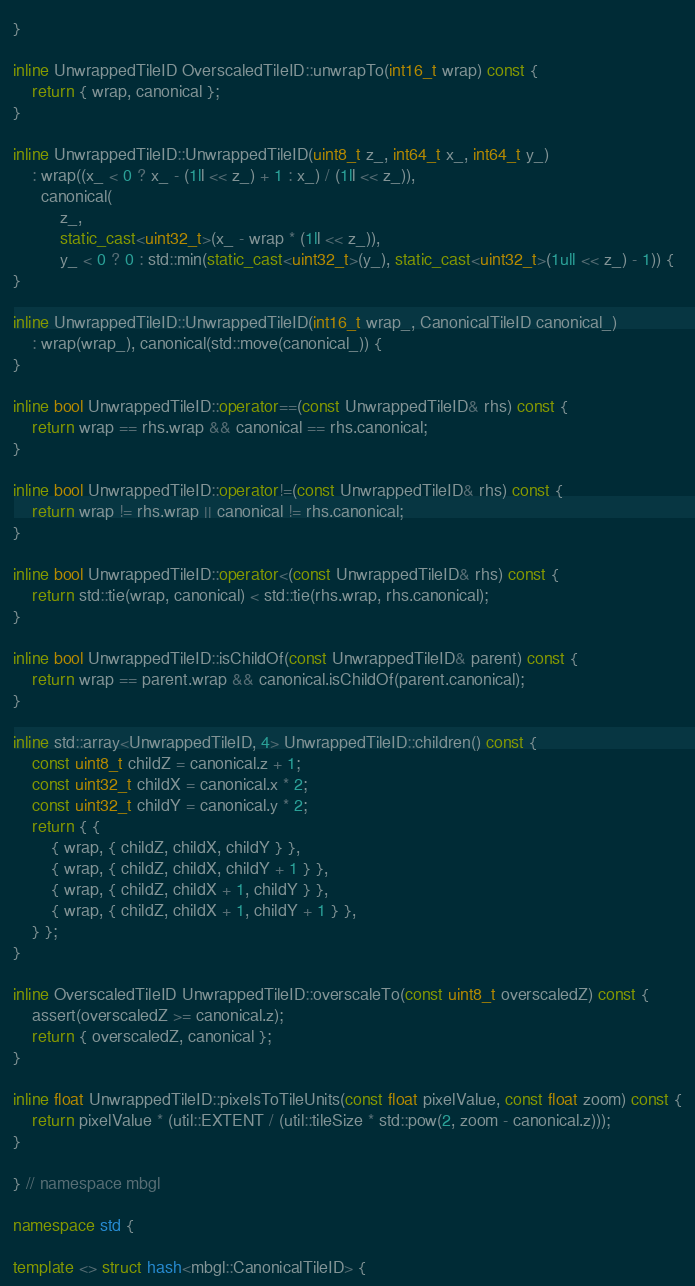<code> <loc_0><loc_0><loc_500><loc_500><_C++_>}

inline UnwrappedTileID OverscaledTileID::unwrapTo(int16_t wrap) const {
    return { wrap, canonical };
}

inline UnwrappedTileID::UnwrappedTileID(uint8_t z_, int64_t x_, int64_t y_)
    : wrap((x_ < 0 ? x_ - (1ll << z_) + 1 : x_) / (1ll << z_)),
      canonical(
          z_,
          static_cast<uint32_t>(x_ - wrap * (1ll << z_)),
          y_ < 0 ? 0 : std::min(static_cast<uint32_t>(y_), static_cast<uint32_t>(1ull << z_) - 1)) {
}

inline UnwrappedTileID::UnwrappedTileID(int16_t wrap_, CanonicalTileID canonical_)
    : wrap(wrap_), canonical(std::move(canonical_)) {
}

inline bool UnwrappedTileID::operator==(const UnwrappedTileID& rhs) const {
    return wrap == rhs.wrap && canonical == rhs.canonical;
}

inline bool UnwrappedTileID::operator!=(const UnwrappedTileID& rhs) const {
    return wrap != rhs.wrap || canonical != rhs.canonical;
}

inline bool UnwrappedTileID::operator<(const UnwrappedTileID& rhs) const {
    return std::tie(wrap, canonical) < std::tie(rhs.wrap, rhs.canonical);
}

inline bool UnwrappedTileID::isChildOf(const UnwrappedTileID& parent) const {
    return wrap == parent.wrap && canonical.isChildOf(parent.canonical);
}

inline std::array<UnwrappedTileID, 4> UnwrappedTileID::children() const {
    const uint8_t childZ = canonical.z + 1;
    const uint32_t childX = canonical.x * 2;
    const uint32_t childY = canonical.y * 2;
    return { {
        { wrap, { childZ, childX, childY } },
        { wrap, { childZ, childX, childY + 1 } },
        { wrap, { childZ, childX + 1, childY } },
        { wrap, { childZ, childX + 1, childY + 1 } },
    } };
}

inline OverscaledTileID UnwrappedTileID::overscaleTo(const uint8_t overscaledZ) const {
    assert(overscaledZ >= canonical.z);
    return { overscaledZ, canonical };
}

inline float UnwrappedTileID::pixelsToTileUnits(const float pixelValue, const float zoom) const {
    return pixelValue * (util::EXTENT / (util::tileSize * std::pow(2, zoom - canonical.z)));
}

} // namespace mbgl

namespace std {

template <> struct hash<mbgl::CanonicalTileID> {</code> 